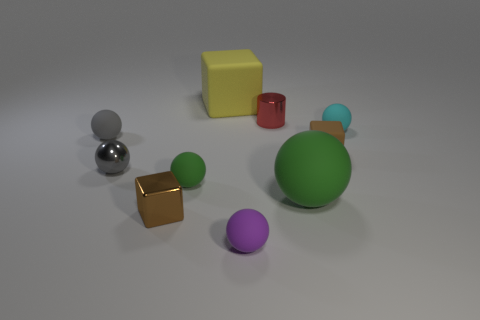Subtract all cyan balls. How many balls are left? 5 Subtract all small green spheres. How many spheres are left? 5 Subtract all red balls. Subtract all cyan cylinders. How many balls are left? 6 Subtract all cylinders. How many objects are left? 9 Add 8 big yellow objects. How many big yellow objects are left? 9 Add 1 small gray metallic objects. How many small gray metallic objects exist? 2 Subtract 0 brown spheres. How many objects are left? 10 Subtract all tiny green matte spheres. Subtract all yellow things. How many objects are left? 8 